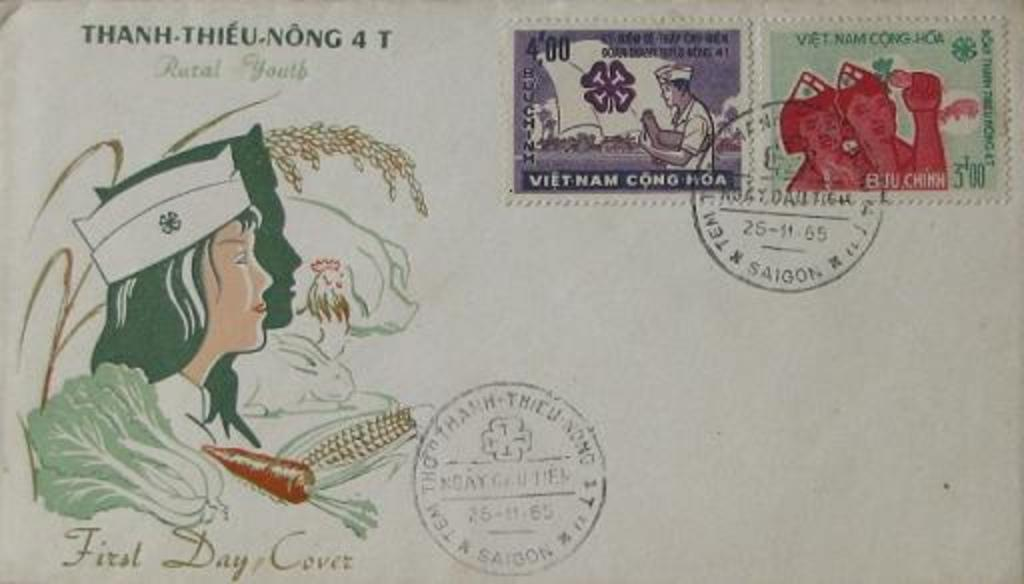<image>
Give a short and clear explanation of the subsequent image. a post with a woman above the words First Day Cover 